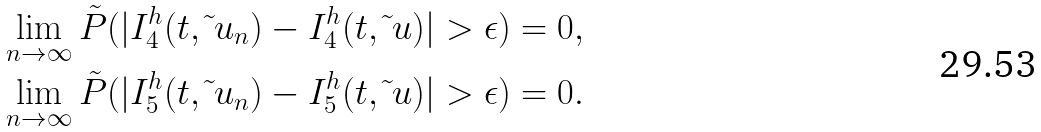<formula> <loc_0><loc_0><loc_500><loc_500>& \quad \lim _ { n \rightarrow \infty } \tilde { P } ( | I ^ { h } _ { 4 } ( t , \tilde { \ } u _ { n } ) - I ^ { h } _ { 4 } ( t , \tilde { \ } u ) | > \epsilon ) = 0 , \\ & \quad \lim _ { n \rightarrow \infty } \tilde { P } ( | I ^ { h } _ { 5 } ( t , \tilde { \ } u _ { n } ) - I ^ { h } _ { 5 } ( t , \tilde { \ } u ) | > \epsilon ) = 0 .</formula> 